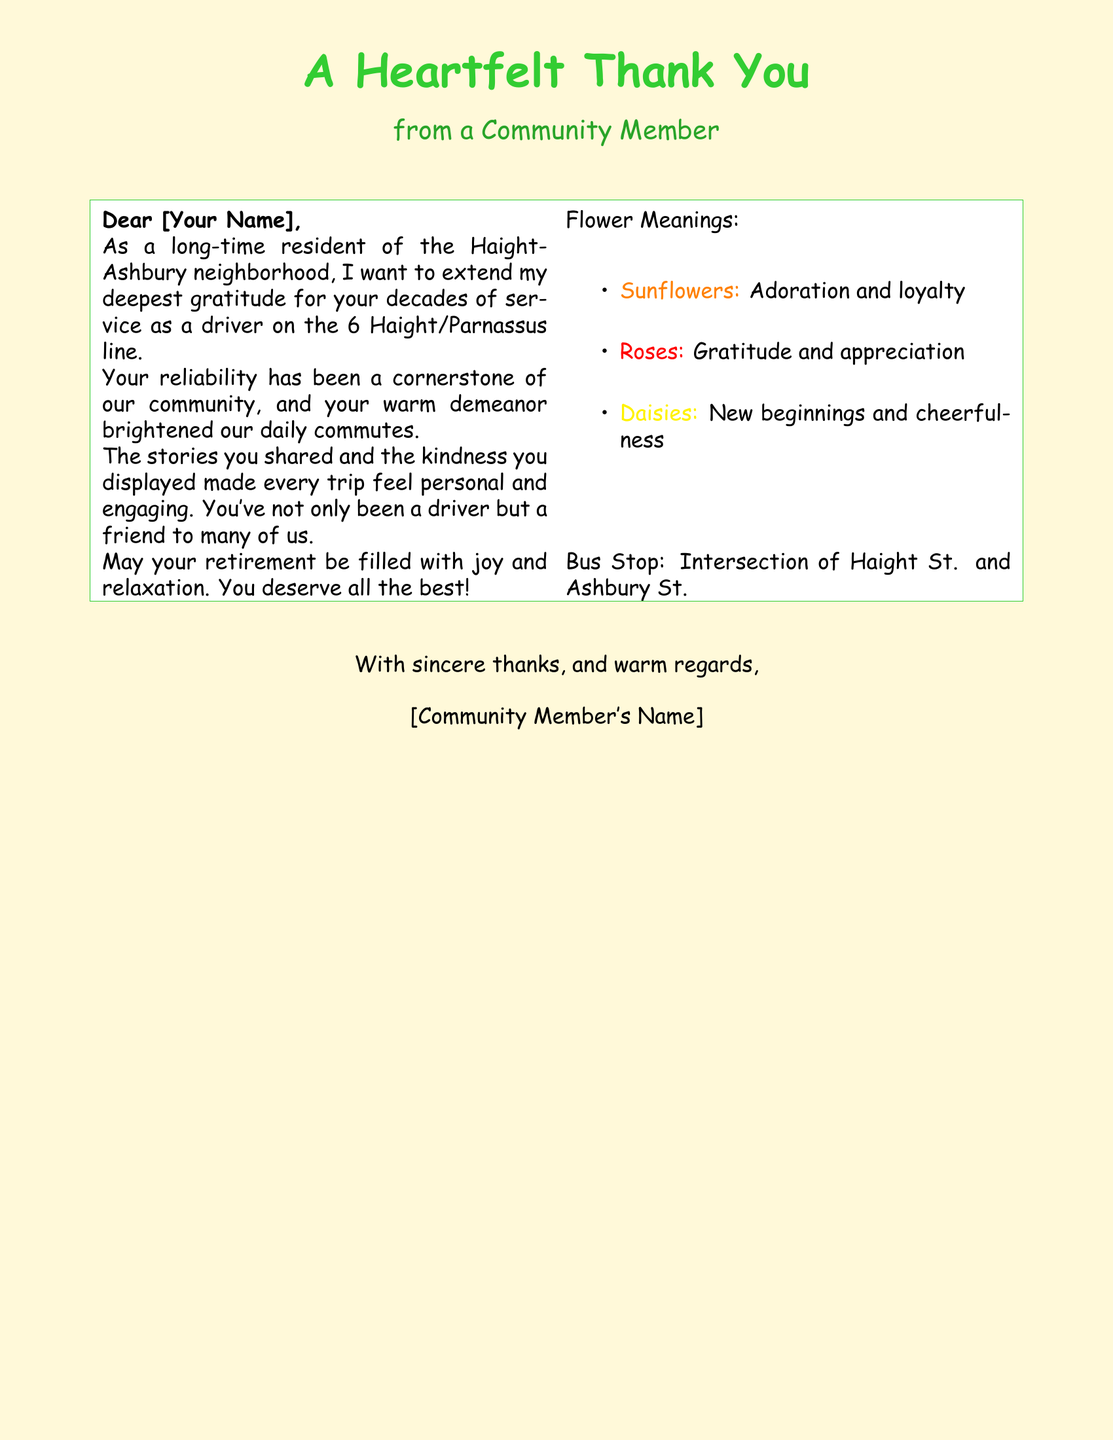What is the greeting on the card? The greeting on the card is "A Heartfelt Thank You."
Answer: A Heartfelt Thank You Who is the card addressed to? The card is addressed to "[Your Name]."
Answer: [Your Name] What is mentioned as a symbol of adoration and loyalty? The document lists "Sunflowers" as a symbol of adoration and loyalty.
Answer: Sunflowers Which street intersection is referenced in the document? The intersection mentioned is "Haight St. and Ashbury St."
Answer: Haight St. and Ashbury St What does the community member wish for the retiree? The community member wishes for the retiree to have "joy and relaxation."
Answer: joy and relaxation How does the community member describe the retiree's demeanor? The community member describes the retiree's demeanor as "warm."
Answer: warm What flower represents gratitude and appreciation? The flower that represents gratitude and appreciation is "Roses."
Answer: Roses What color is used for the backdrop of the card? The backdrop color of the card is a shade of yellow, specifically "busyellow."
Answer: busyellow 